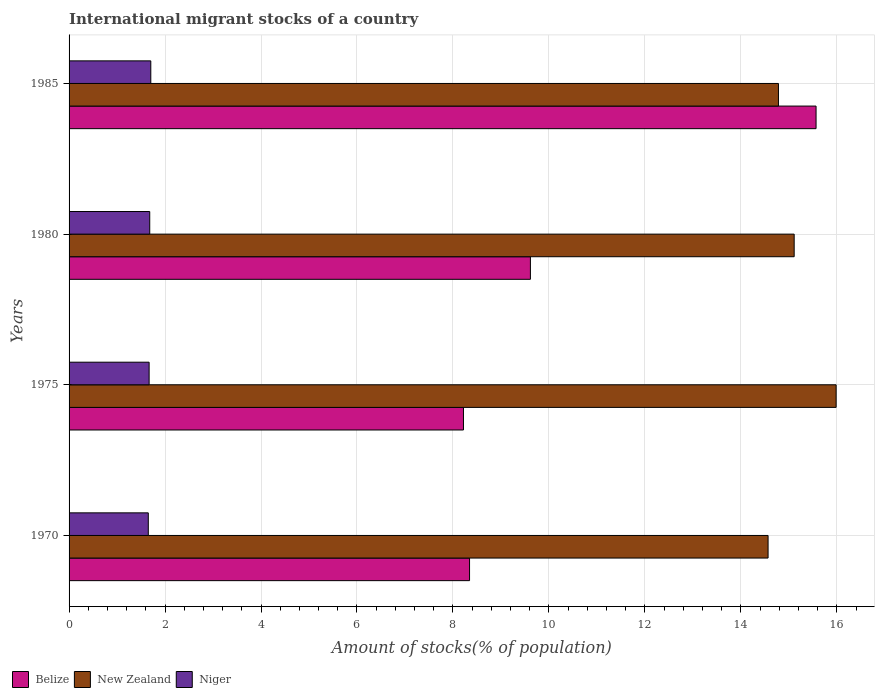Are the number of bars on each tick of the Y-axis equal?
Offer a very short reply. Yes. How many bars are there on the 3rd tick from the top?
Offer a very short reply. 3. How many bars are there on the 2nd tick from the bottom?
Keep it short and to the point. 3. In how many cases, is the number of bars for a given year not equal to the number of legend labels?
Ensure brevity in your answer.  0. What is the amount of stocks in in Niger in 1985?
Make the answer very short. 1.7. Across all years, what is the maximum amount of stocks in in Belize?
Give a very brief answer. 15.57. Across all years, what is the minimum amount of stocks in in Belize?
Your answer should be very brief. 8.22. In which year was the amount of stocks in in Niger maximum?
Your response must be concise. 1985. What is the total amount of stocks in in Niger in the graph?
Your answer should be very brief. 6.7. What is the difference between the amount of stocks in in Belize in 1970 and that in 1975?
Your response must be concise. 0.13. What is the difference between the amount of stocks in in New Zealand in 1970 and the amount of stocks in in Niger in 1975?
Offer a very short reply. 12.9. What is the average amount of stocks in in Niger per year?
Offer a very short reply. 1.68. In the year 1985, what is the difference between the amount of stocks in in Niger and amount of stocks in in Belize?
Provide a succinct answer. -13.86. In how many years, is the amount of stocks in in Belize greater than 10 %?
Your response must be concise. 1. What is the ratio of the amount of stocks in in Belize in 1970 to that in 1985?
Keep it short and to the point. 0.54. Is the difference between the amount of stocks in in Niger in 1980 and 1985 greater than the difference between the amount of stocks in in Belize in 1980 and 1985?
Offer a very short reply. Yes. What is the difference between the highest and the second highest amount of stocks in in Niger?
Ensure brevity in your answer.  0.02. What is the difference between the highest and the lowest amount of stocks in in Belize?
Offer a terse response. 7.35. In how many years, is the amount of stocks in in New Zealand greater than the average amount of stocks in in New Zealand taken over all years?
Provide a short and direct response. 1. Is the sum of the amount of stocks in in New Zealand in 1970 and 1975 greater than the maximum amount of stocks in in Belize across all years?
Provide a short and direct response. Yes. What does the 2nd bar from the top in 1980 represents?
Offer a terse response. New Zealand. What does the 3rd bar from the bottom in 1975 represents?
Give a very brief answer. Niger. How many bars are there?
Ensure brevity in your answer.  12. Are all the bars in the graph horizontal?
Make the answer very short. Yes. What is the difference between two consecutive major ticks on the X-axis?
Your response must be concise. 2. Are the values on the major ticks of X-axis written in scientific E-notation?
Make the answer very short. No. Does the graph contain any zero values?
Your answer should be very brief. No. Does the graph contain grids?
Keep it short and to the point. Yes. Where does the legend appear in the graph?
Provide a succinct answer. Bottom left. How are the legend labels stacked?
Your answer should be compact. Horizontal. What is the title of the graph?
Your answer should be compact. International migrant stocks of a country. What is the label or title of the X-axis?
Keep it short and to the point. Amount of stocks(% of population). What is the label or title of the Y-axis?
Offer a terse response. Years. What is the Amount of stocks(% of population) of Belize in 1970?
Offer a terse response. 8.35. What is the Amount of stocks(% of population) of New Zealand in 1970?
Your answer should be compact. 14.57. What is the Amount of stocks(% of population) of Niger in 1970?
Your response must be concise. 1.65. What is the Amount of stocks(% of population) of Belize in 1975?
Offer a terse response. 8.22. What is the Amount of stocks(% of population) of New Zealand in 1975?
Your answer should be compact. 15.99. What is the Amount of stocks(% of population) of Niger in 1975?
Offer a terse response. 1.67. What is the Amount of stocks(% of population) in Belize in 1980?
Your answer should be compact. 9.61. What is the Amount of stocks(% of population) of New Zealand in 1980?
Give a very brief answer. 15.11. What is the Amount of stocks(% of population) in Niger in 1980?
Provide a succinct answer. 1.68. What is the Amount of stocks(% of population) in Belize in 1985?
Give a very brief answer. 15.57. What is the Amount of stocks(% of population) of New Zealand in 1985?
Offer a terse response. 14.78. What is the Amount of stocks(% of population) in Niger in 1985?
Offer a terse response. 1.7. Across all years, what is the maximum Amount of stocks(% of population) in Belize?
Provide a succinct answer. 15.57. Across all years, what is the maximum Amount of stocks(% of population) of New Zealand?
Your answer should be very brief. 15.99. Across all years, what is the maximum Amount of stocks(% of population) of Niger?
Offer a terse response. 1.7. Across all years, what is the minimum Amount of stocks(% of population) in Belize?
Make the answer very short. 8.22. Across all years, what is the minimum Amount of stocks(% of population) of New Zealand?
Offer a terse response. 14.57. Across all years, what is the minimum Amount of stocks(% of population) of Niger?
Make the answer very short. 1.65. What is the total Amount of stocks(% of population) in Belize in the graph?
Offer a very short reply. 41.75. What is the total Amount of stocks(% of population) in New Zealand in the graph?
Your answer should be very brief. 60.45. What is the total Amount of stocks(% of population) of Niger in the graph?
Ensure brevity in your answer.  6.7. What is the difference between the Amount of stocks(% of population) in Belize in 1970 and that in 1975?
Offer a terse response. 0.13. What is the difference between the Amount of stocks(% of population) of New Zealand in 1970 and that in 1975?
Make the answer very short. -1.42. What is the difference between the Amount of stocks(% of population) in Niger in 1970 and that in 1975?
Your answer should be compact. -0.02. What is the difference between the Amount of stocks(% of population) of Belize in 1970 and that in 1980?
Offer a very short reply. -1.27. What is the difference between the Amount of stocks(% of population) in New Zealand in 1970 and that in 1980?
Give a very brief answer. -0.54. What is the difference between the Amount of stocks(% of population) of Niger in 1970 and that in 1980?
Offer a very short reply. -0.03. What is the difference between the Amount of stocks(% of population) in Belize in 1970 and that in 1985?
Offer a terse response. -7.22. What is the difference between the Amount of stocks(% of population) in New Zealand in 1970 and that in 1985?
Your answer should be compact. -0.22. What is the difference between the Amount of stocks(% of population) of Niger in 1970 and that in 1985?
Give a very brief answer. -0.05. What is the difference between the Amount of stocks(% of population) in Belize in 1975 and that in 1980?
Offer a very short reply. -1.4. What is the difference between the Amount of stocks(% of population) in New Zealand in 1975 and that in 1980?
Your response must be concise. 0.87. What is the difference between the Amount of stocks(% of population) in Niger in 1975 and that in 1980?
Provide a short and direct response. -0.01. What is the difference between the Amount of stocks(% of population) in Belize in 1975 and that in 1985?
Keep it short and to the point. -7.35. What is the difference between the Amount of stocks(% of population) in New Zealand in 1975 and that in 1985?
Offer a very short reply. 1.2. What is the difference between the Amount of stocks(% of population) of Niger in 1975 and that in 1985?
Offer a terse response. -0.03. What is the difference between the Amount of stocks(% of population) in Belize in 1980 and that in 1985?
Keep it short and to the point. -5.95. What is the difference between the Amount of stocks(% of population) in New Zealand in 1980 and that in 1985?
Your answer should be very brief. 0.33. What is the difference between the Amount of stocks(% of population) of Niger in 1980 and that in 1985?
Your response must be concise. -0.02. What is the difference between the Amount of stocks(% of population) in Belize in 1970 and the Amount of stocks(% of population) in New Zealand in 1975?
Make the answer very short. -7.64. What is the difference between the Amount of stocks(% of population) in Belize in 1970 and the Amount of stocks(% of population) in Niger in 1975?
Your response must be concise. 6.68. What is the difference between the Amount of stocks(% of population) of New Zealand in 1970 and the Amount of stocks(% of population) of Niger in 1975?
Offer a very short reply. 12.9. What is the difference between the Amount of stocks(% of population) in Belize in 1970 and the Amount of stocks(% of population) in New Zealand in 1980?
Provide a short and direct response. -6.77. What is the difference between the Amount of stocks(% of population) in Belize in 1970 and the Amount of stocks(% of population) in Niger in 1980?
Give a very brief answer. 6.67. What is the difference between the Amount of stocks(% of population) in New Zealand in 1970 and the Amount of stocks(% of population) in Niger in 1980?
Ensure brevity in your answer.  12.89. What is the difference between the Amount of stocks(% of population) of Belize in 1970 and the Amount of stocks(% of population) of New Zealand in 1985?
Give a very brief answer. -6.44. What is the difference between the Amount of stocks(% of population) in Belize in 1970 and the Amount of stocks(% of population) in Niger in 1985?
Give a very brief answer. 6.64. What is the difference between the Amount of stocks(% of population) of New Zealand in 1970 and the Amount of stocks(% of population) of Niger in 1985?
Provide a short and direct response. 12.86. What is the difference between the Amount of stocks(% of population) in Belize in 1975 and the Amount of stocks(% of population) in New Zealand in 1980?
Offer a terse response. -6.89. What is the difference between the Amount of stocks(% of population) of Belize in 1975 and the Amount of stocks(% of population) of Niger in 1980?
Provide a succinct answer. 6.54. What is the difference between the Amount of stocks(% of population) in New Zealand in 1975 and the Amount of stocks(% of population) in Niger in 1980?
Offer a very short reply. 14.3. What is the difference between the Amount of stocks(% of population) in Belize in 1975 and the Amount of stocks(% of population) in New Zealand in 1985?
Make the answer very short. -6.56. What is the difference between the Amount of stocks(% of population) of Belize in 1975 and the Amount of stocks(% of population) of Niger in 1985?
Your answer should be compact. 6.52. What is the difference between the Amount of stocks(% of population) of New Zealand in 1975 and the Amount of stocks(% of population) of Niger in 1985?
Offer a very short reply. 14.28. What is the difference between the Amount of stocks(% of population) of Belize in 1980 and the Amount of stocks(% of population) of New Zealand in 1985?
Your answer should be very brief. -5.17. What is the difference between the Amount of stocks(% of population) in Belize in 1980 and the Amount of stocks(% of population) in Niger in 1985?
Provide a short and direct response. 7.91. What is the difference between the Amount of stocks(% of population) of New Zealand in 1980 and the Amount of stocks(% of population) of Niger in 1985?
Provide a short and direct response. 13.41. What is the average Amount of stocks(% of population) of Belize per year?
Keep it short and to the point. 10.44. What is the average Amount of stocks(% of population) of New Zealand per year?
Provide a short and direct response. 15.11. What is the average Amount of stocks(% of population) of Niger per year?
Provide a short and direct response. 1.68. In the year 1970, what is the difference between the Amount of stocks(% of population) in Belize and Amount of stocks(% of population) in New Zealand?
Your answer should be compact. -6.22. In the year 1970, what is the difference between the Amount of stocks(% of population) in Belize and Amount of stocks(% of population) in Niger?
Your answer should be very brief. 6.69. In the year 1970, what is the difference between the Amount of stocks(% of population) in New Zealand and Amount of stocks(% of population) in Niger?
Make the answer very short. 12.92. In the year 1975, what is the difference between the Amount of stocks(% of population) in Belize and Amount of stocks(% of population) in New Zealand?
Give a very brief answer. -7.77. In the year 1975, what is the difference between the Amount of stocks(% of population) in Belize and Amount of stocks(% of population) in Niger?
Make the answer very short. 6.55. In the year 1975, what is the difference between the Amount of stocks(% of population) in New Zealand and Amount of stocks(% of population) in Niger?
Your answer should be very brief. 14.32. In the year 1980, what is the difference between the Amount of stocks(% of population) in Belize and Amount of stocks(% of population) in New Zealand?
Make the answer very short. -5.5. In the year 1980, what is the difference between the Amount of stocks(% of population) of Belize and Amount of stocks(% of population) of Niger?
Provide a short and direct response. 7.93. In the year 1980, what is the difference between the Amount of stocks(% of population) in New Zealand and Amount of stocks(% of population) in Niger?
Ensure brevity in your answer.  13.43. In the year 1985, what is the difference between the Amount of stocks(% of population) in Belize and Amount of stocks(% of population) in New Zealand?
Give a very brief answer. 0.78. In the year 1985, what is the difference between the Amount of stocks(% of population) of Belize and Amount of stocks(% of population) of Niger?
Make the answer very short. 13.86. In the year 1985, what is the difference between the Amount of stocks(% of population) of New Zealand and Amount of stocks(% of population) of Niger?
Your response must be concise. 13.08. What is the ratio of the Amount of stocks(% of population) of Belize in 1970 to that in 1975?
Your answer should be compact. 1.02. What is the ratio of the Amount of stocks(% of population) in New Zealand in 1970 to that in 1975?
Ensure brevity in your answer.  0.91. What is the ratio of the Amount of stocks(% of population) in Belize in 1970 to that in 1980?
Keep it short and to the point. 0.87. What is the ratio of the Amount of stocks(% of population) of Niger in 1970 to that in 1980?
Offer a terse response. 0.98. What is the ratio of the Amount of stocks(% of population) in Belize in 1970 to that in 1985?
Your answer should be compact. 0.54. What is the ratio of the Amount of stocks(% of population) of New Zealand in 1970 to that in 1985?
Give a very brief answer. 0.99. What is the ratio of the Amount of stocks(% of population) in Niger in 1970 to that in 1985?
Provide a succinct answer. 0.97. What is the ratio of the Amount of stocks(% of population) in Belize in 1975 to that in 1980?
Offer a very short reply. 0.85. What is the ratio of the Amount of stocks(% of population) of New Zealand in 1975 to that in 1980?
Provide a short and direct response. 1.06. What is the ratio of the Amount of stocks(% of population) in Niger in 1975 to that in 1980?
Provide a succinct answer. 0.99. What is the ratio of the Amount of stocks(% of population) in Belize in 1975 to that in 1985?
Your answer should be very brief. 0.53. What is the ratio of the Amount of stocks(% of population) in New Zealand in 1975 to that in 1985?
Ensure brevity in your answer.  1.08. What is the ratio of the Amount of stocks(% of population) of Niger in 1975 to that in 1985?
Offer a terse response. 0.98. What is the ratio of the Amount of stocks(% of population) in Belize in 1980 to that in 1985?
Make the answer very short. 0.62. What is the ratio of the Amount of stocks(% of population) of New Zealand in 1980 to that in 1985?
Keep it short and to the point. 1.02. What is the difference between the highest and the second highest Amount of stocks(% of population) of Belize?
Make the answer very short. 5.95. What is the difference between the highest and the second highest Amount of stocks(% of population) of New Zealand?
Make the answer very short. 0.87. What is the difference between the highest and the second highest Amount of stocks(% of population) of Niger?
Your answer should be very brief. 0.02. What is the difference between the highest and the lowest Amount of stocks(% of population) in Belize?
Give a very brief answer. 7.35. What is the difference between the highest and the lowest Amount of stocks(% of population) of New Zealand?
Give a very brief answer. 1.42. What is the difference between the highest and the lowest Amount of stocks(% of population) in Niger?
Offer a very short reply. 0.05. 